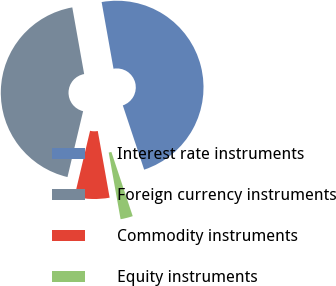Convert chart to OTSL. <chart><loc_0><loc_0><loc_500><loc_500><pie_chart><fcel>Interest rate instruments<fcel>Foreign currency instruments<fcel>Commodity instruments<fcel>Equity instruments<nl><fcel>47.7%<fcel>43.49%<fcel>6.51%<fcel>2.3%<nl></chart> 